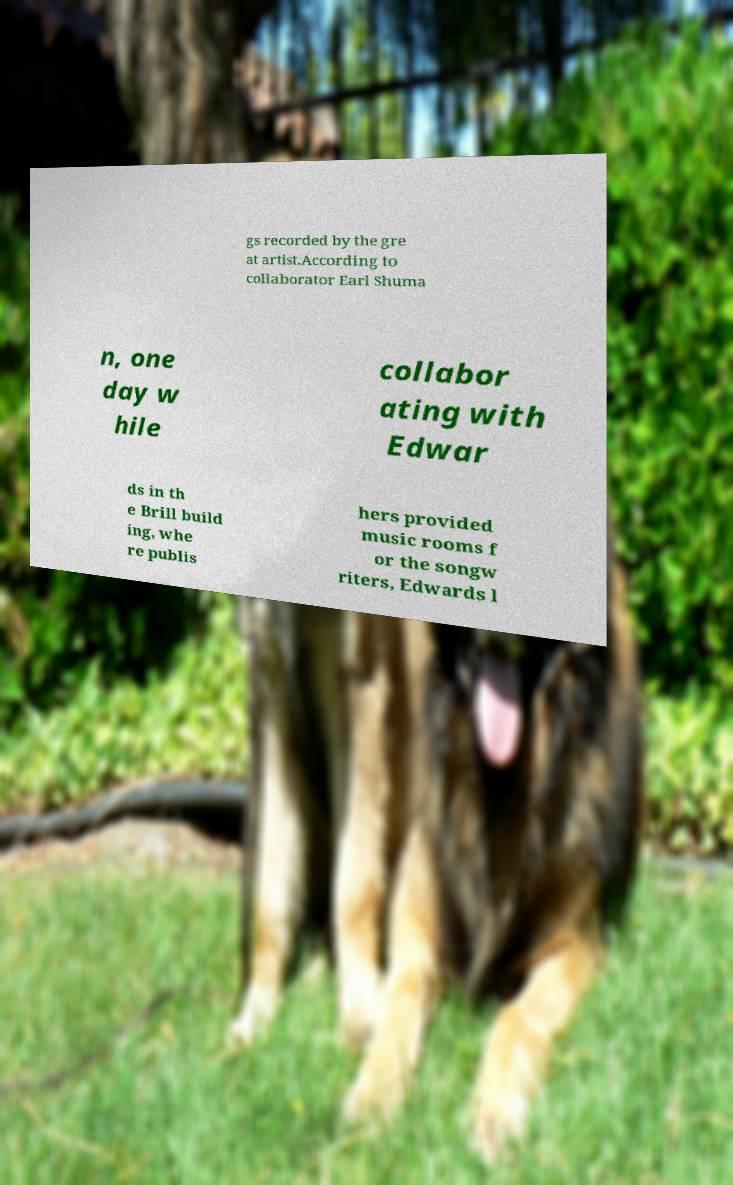I need the written content from this picture converted into text. Can you do that? gs recorded by the gre at artist.According to collaborator Earl Shuma n, one day w hile collabor ating with Edwar ds in th e Brill build ing, whe re publis hers provided music rooms f or the songw riters, Edwards l 